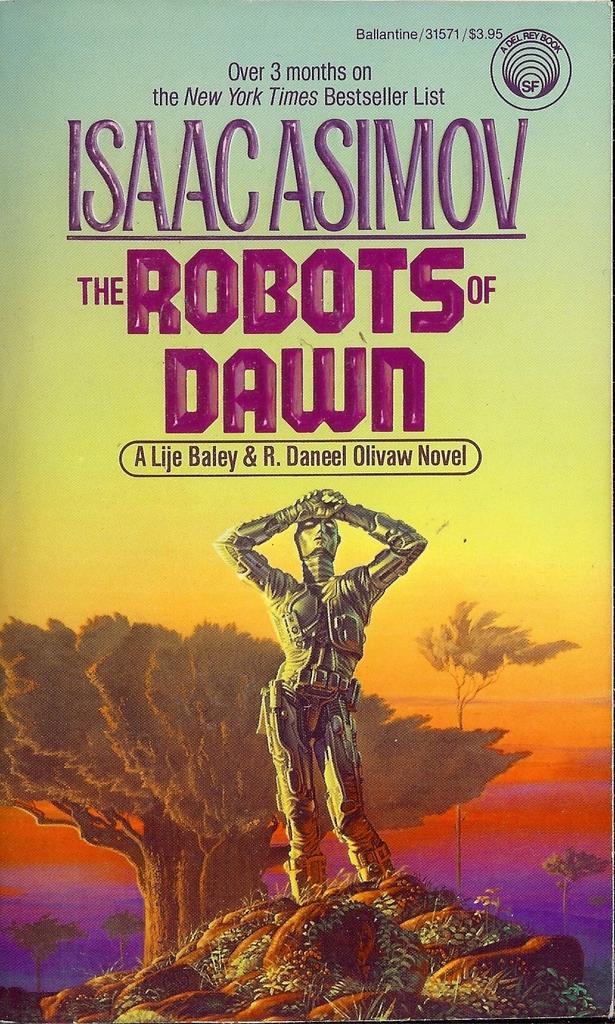Who is the author of the book?
Make the answer very short. Isaac asimov. 